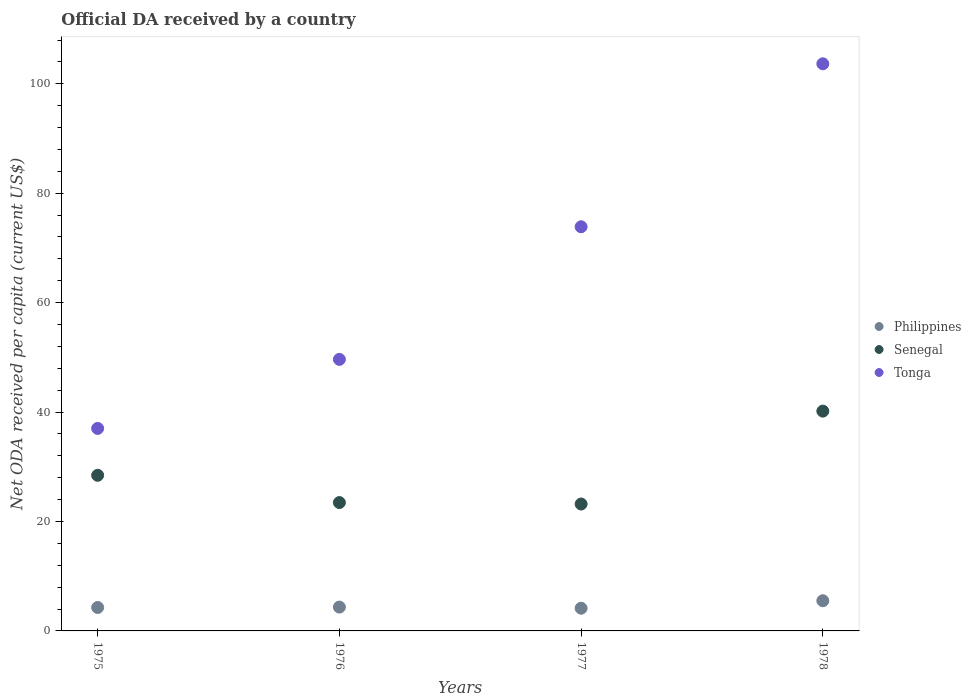What is the ODA received in in Senegal in 1976?
Offer a very short reply. 23.46. Across all years, what is the maximum ODA received in in Tonga?
Keep it short and to the point. 103.66. Across all years, what is the minimum ODA received in in Tonga?
Offer a very short reply. 37.01. In which year was the ODA received in in Senegal maximum?
Your answer should be very brief. 1978. In which year was the ODA received in in Senegal minimum?
Offer a very short reply. 1977. What is the total ODA received in in Philippines in the graph?
Offer a very short reply. 18.31. What is the difference between the ODA received in in Tonga in 1977 and that in 1978?
Provide a short and direct response. -29.79. What is the difference between the ODA received in in Tonga in 1978 and the ODA received in in Senegal in 1977?
Offer a terse response. 80.46. What is the average ODA received in in Senegal per year?
Your answer should be very brief. 28.82. In the year 1976, what is the difference between the ODA received in in Senegal and ODA received in in Philippines?
Your response must be concise. 19.1. What is the ratio of the ODA received in in Senegal in 1976 to that in 1977?
Your response must be concise. 1.01. Is the difference between the ODA received in in Senegal in 1975 and 1978 greater than the difference between the ODA received in in Philippines in 1975 and 1978?
Provide a succinct answer. No. What is the difference between the highest and the second highest ODA received in in Senegal?
Ensure brevity in your answer.  11.73. What is the difference between the highest and the lowest ODA received in in Tonga?
Make the answer very short. 66.64. In how many years, is the ODA received in in Philippines greater than the average ODA received in in Philippines taken over all years?
Ensure brevity in your answer.  1. Is the sum of the ODA received in in Tonga in 1976 and 1978 greater than the maximum ODA received in in Philippines across all years?
Ensure brevity in your answer.  Yes. Is the ODA received in in Tonga strictly greater than the ODA received in in Senegal over the years?
Give a very brief answer. Yes. Is the ODA received in in Philippines strictly less than the ODA received in in Senegal over the years?
Offer a very short reply. Yes. How many dotlines are there?
Give a very brief answer. 3. What is the difference between two consecutive major ticks on the Y-axis?
Make the answer very short. 20. Does the graph contain any zero values?
Make the answer very short. No. Where does the legend appear in the graph?
Make the answer very short. Center right. What is the title of the graph?
Ensure brevity in your answer.  Official DA received by a country. Does "High income: OECD" appear as one of the legend labels in the graph?
Offer a very short reply. No. What is the label or title of the X-axis?
Give a very brief answer. Years. What is the label or title of the Y-axis?
Your response must be concise. Net ODA received per capita (current US$). What is the Net ODA received per capita (current US$) in Philippines in 1975?
Offer a very short reply. 4.28. What is the Net ODA received per capita (current US$) of Senegal in 1975?
Keep it short and to the point. 28.44. What is the Net ODA received per capita (current US$) in Tonga in 1975?
Your response must be concise. 37.01. What is the Net ODA received per capita (current US$) of Philippines in 1976?
Give a very brief answer. 4.36. What is the Net ODA received per capita (current US$) in Senegal in 1976?
Provide a succinct answer. 23.46. What is the Net ODA received per capita (current US$) in Tonga in 1976?
Your response must be concise. 49.63. What is the Net ODA received per capita (current US$) of Philippines in 1977?
Provide a short and direct response. 4.15. What is the Net ODA received per capita (current US$) in Senegal in 1977?
Give a very brief answer. 23.19. What is the Net ODA received per capita (current US$) of Tonga in 1977?
Ensure brevity in your answer.  73.87. What is the Net ODA received per capita (current US$) in Philippines in 1978?
Offer a very short reply. 5.52. What is the Net ODA received per capita (current US$) of Senegal in 1978?
Provide a succinct answer. 40.17. What is the Net ODA received per capita (current US$) of Tonga in 1978?
Offer a very short reply. 103.66. Across all years, what is the maximum Net ODA received per capita (current US$) in Philippines?
Give a very brief answer. 5.52. Across all years, what is the maximum Net ODA received per capita (current US$) of Senegal?
Your answer should be very brief. 40.17. Across all years, what is the maximum Net ODA received per capita (current US$) in Tonga?
Make the answer very short. 103.66. Across all years, what is the minimum Net ODA received per capita (current US$) of Philippines?
Give a very brief answer. 4.15. Across all years, what is the minimum Net ODA received per capita (current US$) in Senegal?
Your response must be concise. 23.19. Across all years, what is the minimum Net ODA received per capita (current US$) in Tonga?
Your answer should be very brief. 37.01. What is the total Net ODA received per capita (current US$) in Philippines in the graph?
Keep it short and to the point. 18.31. What is the total Net ODA received per capita (current US$) of Senegal in the graph?
Keep it short and to the point. 115.27. What is the total Net ODA received per capita (current US$) in Tonga in the graph?
Ensure brevity in your answer.  264.17. What is the difference between the Net ODA received per capita (current US$) in Philippines in 1975 and that in 1976?
Ensure brevity in your answer.  -0.07. What is the difference between the Net ODA received per capita (current US$) of Senegal in 1975 and that in 1976?
Offer a very short reply. 4.98. What is the difference between the Net ODA received per capita (current US$) in Tonga in 1975 and that in 1976?
Offer a terse response. -12.62. What is the difference between the Net ODA received per capita (current US$) in Philippines in 1975 and that in 1977?
Give a very brief answer. 0.13. What is the difference between the Net ODA received per capita (current US$) in Senegal in 1975 and that in 1977?
Keep it short and to the point. 5.25. What is the difference between the Net ODA received per capita (current US$) in Tonga in 1975 and that in 1977?
Provide a succinct answer. -36.85. What is the difference between the Net ODA received per capita (current US$) of Philippines in 1975 and that in 1978?
Make the answer very short. -1.23. What is the difference between the Net ODA received per capita (current US$) of Senegal in 1975 and that in 1978?
Offer a terse response. -11.73. What is the difference between the Net ODA received per capita (current US$) in Tonga in 1975 and that in 1978?
Offer a terse response. -66.64. What is the difference between the Net ODA received per capita (current US$) in Philippines in 1976 and that in 1977?
Provide a short and direct response. 0.21. What is the difference between the Net ODA received per capita (current US$) in Senegal in 1976 and that in 1977?
Your answer should be very brief. 0.27. What is the difference between the Net ODA received per capita (current US$) in Tonga in 1976 and that in 1977?
Your answer should be very brief. -24.24. What is the difference between the Net ODA received per capita (current US$) of Philippines in 1976 and that in 1978?
Offer a terse response. -1.16. What is the difference between the Net ODA received per capita (current US$) in Senegal in 1976 and that in 1978?
Give a very brief answer. -16.71. What is the difference between the Net ODA received per capita (current US$) in Tonga in 1976 and that in 1978?
Give a very brief answer. -54.02. What is the difference between the Net ODA received per capita (current US$) of Philippines in 1977 and that in 1978?
Give a very brief answer. -1.37. What is the difference between the Net ODA received per capita (current US$) in Senegal in 1977 and that in 1978?
Make the answer very short. -16.98. What is the difference between the Net ODA received per capita (current US$) of Tonga in 1977 and that in 1978?
Offer a terse response. -29.79. What is the difference between the Net ODA received per capita (current US$) in Philippines in 1975 and the Net ODA received per capita (current US$) in Senegal in 1976?
Offer a terse response. -19.18. What is the difference between the Net ODA received per capita (current US$) in Philippines in 1975 and the Net ODA received per capita (current US$) in Tonga in 1976?
Offer a very short reply. -45.35. What is the difference between the Net ODA received per capita (current US$) in Senegal in 1975 and the Net ODA received per capita (current US$) in Tonga in 1976?
Give a very brief answer. -21.19. What is the difference between the Net ODA received per capita (current US$) in Philippines in 1975 and the Net ODA received per capita (current US$) in Senegal in 1977?
Provide a succinct answer. -18.91. What is the difference between the Net ODA received per capita (current US$) of Philippines in 1975 and the Net ODA received per capita (current US$) of Tonga in 1977?
Offer a very short reply. -69.59. What is the difference between the Net ODA received per capita (current US$) of Senegal in 1975 and the Net ODA received per capita (current US$) of Tonga in 1977?
Give a very brief answer. -45.42. What is the difference between the Net ODA received per capita (current US$) of Philippines in 1975 and the Net ODA received per capita (current US$) of Senegal in 1978?
Offer a very short reply. -35.89. What is the difference between the Net ODA received per capita (current US$) in Philippines in 1975 and the Net ODA received per capita (current US$) in Tonga in 1978?
Provide a short and direct response. -99.37. What is the difference between the Net ODA received per capita (current US$) of Senegal in 1975 and the Net ODA received per capita (current US$) of Tonga in 1978?
Make the answer very short. -75.21. What is the difference between the Net ODA received per capita (current US$) in Philippines in 1976 and the Net ODA received per capita (current US$) in Senegal in 1977?
Provide a short and direct response. -18.84. What is the difference between the Net ODA received per capita (current US$) in Philippines in 1976 and the Net ODA received per capita (current US$) in Tonga in 1977?
Offer a terse response. -69.51. What is the difference between the Net ODA received per capita (current US$) in Senegal in 1976 and the Net ODA received per capita (current US$) in Tonga in 1977?
Your answer should be very brief. -50.41. What is the difference between the Net ODA received per capita (current US$) of Philippines in 1976 and the Net ODA received per capita (current US$) of Senegal in 1978?
Keep it short and to the point. -35.82. What is the difference between the Net ODA received per capita (current US$) in Philippines in 1976 and the Net ODA received per capita (current US$) in Tonga in 1978?
Provide a succinct answer. -99.3. What is the difference between the Net ODA received per capita (current US$) of Senegal in 1976 and the Net ODA received per capita (current US$) of Tonga in 1978?
Ensure brevity in your answer.  -80.2. What is the difference between the Net ODA received per capita (current US$) in Philippines in 1977 and the Net ODA received per capita (current US$) in Senegal in 1978?
Offer a terse response. -36.02. What is the difference between the Net ODA received per capita (current US$) in Philippines in 1977 and the Net ODA received per capita (current US$) in Tonga in 1978?
Provide a succinct answer. -99.51. What is the difference between the Net ODA received per capita (current US$) of Senegal in 1977 and the Net ODA received per capita (current US$) of Tonga in 1978?
Give a very brief answer. -80.46. What is the average Net ODA received per capita (current US$) in Philippines per year?
Make the answer very short. 4.58. What is the average Net ODA received per capita (current US$) in Senegal per year?
Ensure brevity in your answer.  28.82. What is the average Net ODA received per capita (current US$) of Tonga per year?
Your response must be concise. 66.04. In the year 1975, what is the difference between the Net ODA received per capita (current US$) of Philippines and Net ODA received per capita (current US$) of Senegal?
Offer a terse response. -24.16. In the year 1975, what is the difference between the Net ODA received per capita (current US$) in Philippines and Net ODA received per capita (current US$) in Tonga?
Your response must be concise. -32.73. In the year 1975, what is the difference between the Net ODA received per capita (current US$) in Senegal and Net ODA received per capita (current US$) in Tonga?
Provide a short and direct response. -8.57. In the year 1976, what is the difference between the Net ODA received per capita (current US$) in Philippines and Net ODA received per capita (current US$) in Senegal?
Provide a succinct answer. -19.1. In the year 1976, what is the difference between the Net ODA received per capita (current US$) in Philippines and Net ODA received per capita (current US$) in Tonga?
Provide a succinct answer. -45.28. In the year 1976, what is the difference between the Net ODA received per capita (current US$) in Senegal and Net ODA received per capita (current US$) in Tonga?
Your answer should be very brief. -26.17. In the year 1977, what is the difference between the Net ODA received per capita (current US$) of Philippines and Net ODA received per capita (current US$) of Senegal?
Your response must be concise. -19.04. In the year 1977, what is the difference between the Net ODA received per capita (current US$) of Philippines and Net ODA received per capita (current US$) of Tonga?
Provide a succinct answer. -69.72. In the year 1977, what is the difference between the Net ODA received per capita (current US$) of Senegal and Net ODA received per capita (current US$) of Tonga?
Provide a short and direct response. -50.67. In the year 1978, what is the difference between the Net ODA received per capita (current US$) of Philippines and Net ODA received per capita (current US$) of Senegal?
Provide a short and direct response. -34.66. In the year 1978, what is the difference between the Net ODA received per capita (current US$) of Philippines and Net ODA received per capita (current US$) of Tonga?
Your answer should be compact. -98.14. In the year 1978, what is the difference between the Net ODA received per capita (current US$) in Senegal and Net ODA received per capita (current US$) in Tonga?
Provide a short and direct response. -63.48. What is the ratio of the Net ODA received per capita (current US$) of Senegal in 1975 to that in 1976?
Provide a succinct answer. 1.21. What is the ratio of the Net ODA received per capita (current US$) in Tonga in 1975 to that in 1976?
Your answer should be compact. 0.75. What is the ratio of the Net ODA received per capita (current US$) of Philippines in 1975 to that in 1977?
Offer a very short reply. 1.03. What is the ratio of the Net ODA received per capita (current US$) in Senegal in 1975 to that in 1977?
Make the answer very short. 1.23. What is the ratio of the Net ODA received per capita (current US$) in Tonga in 1975 to that in 1977?
Offer a very short reply. 0.5. What is the ratio of the Net ODA received per capita (current US$) of Philippines in 1975 to that in 1978?
Provide a short and direct response. 0.78. What is the ratio of the Net ODA received per capita (current US$) in Senegal in 1975 to that in 1978?
Give a very brief answer. 0.71. What is the ratio of the Net ODA received per capita (current US$) in Tonga in 1975 to that in 1978?
Your answer should be compact. 0.36. What is the ratio of the Net ODA received per capita (current US$) of Philippines in 1976 to that in 1977?
Offer a terse response. 1.05. What is the ratio of the Net ODA received per capita (current US$) in Senegal in 1976 to that in 1977?
Offer a very short reply. 1.01. What is the ratio of the Net ODA received per capita (current US$) in Tonga in 1976 to that in 1977?
Your answer should be compact. 0.67. What is the ratio of the Net ODA received per capita (current US$) of Philippines in 1976 to that in 1978?
Ensure brevity in your answer.  0.79. What is the ratio of the Net ODA received per capita (current US$) of Senegal in 1976 to that in 1978?
Offer a terse response. 0.58. What is the ratio of the Net ODA received per capita (current US$) of Tonga in 1976 to that in 1978?
Ensure brevity in your answer.  0.48. What is the ratio of the Net ODA received per capita (current US$) of Philippines in 1977 to that in 1978?
Make the answer very short. 0.75. What is the ratio of the Net ODA received per capita (current US$) of Senegal in 1977 to that in 1978?
Offer a very short reply. 0.58. What is the ratio of the Net ODA received per capita (current US$) of Tonga in 1977 to that in 1978?
Your answer should be very brief. 0.71. What is the difference between the highest and the second highest Net ODA received per capita (current US$) of Philippines?
Offer a very short reply. 1.16. What is the difference between the highest and the second highest Net ODA received per capita (current US$) of Senegal?
Give a very brief answer. 11.73. What is the difference between the highest and the second highest Net ODA received per capita (current US$) of Tonga?
Your answer should be very brief. 29.79. What is the difference between the highest and the lowest Net ODA received per capita (current US$) in Philippines?
Give a very brief answer. 1.37. What is the difference between the highest and the lowest Net ODA received per capita (current US$) in Senegal?
Make the answer very short. 16.98. What is the difference between the highest and the lowest Net ODA received per capita (current US$) in Tonga?
Make the answer very short. 66.64. 